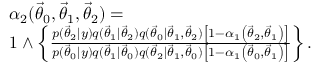Convert formula to latex. <formula><loc_0><loc_0><loc_500><loc_500>\begin{array} { r l } & { \alpha _ { 2 } ( { \vec { \theta } } _ { 0 } , { \vec { \theta } } _ { 1 } , { \vec { \theta } } _ { 2 } ) = } \\ & { 1 \wedge \left \{ \frac { p ( { \vec { \theta } } _ { 2 } | y ) q ( { \vec { \theta } } _ { 1 } | { \vec { \theta } } _ { 2 } ) q ( { \vec { \theta } } _ { 0 } | { \vec { \theta } } _ { 1 } , { \vec { \theta } } _ { 2 } ) \left [ 1 - \alpha _ { 1 } \left ( { \vec { \theta } } _ { 2 } , { \vec { \theta } } _ { 1 } \right ) \right ] } { p ( { \vec { \theta } } _ { 0 } | y ) q ( { \vec { \theta } } _ { 1 } | { \vec { \theta } } _ { 0 } ) q ( { \vec { \theta } } _ { 2 } | { \vec { \theta } } _ { 1 } , { \vec { \theta } } _ { 0 } ) \left [ 1 - \alpha _ { 1 } \left ( { \vec { \theta } } _ { 0 } , { \vec { \theta } } _ { 1 } \right ) \right ] } \right \} . } \end{array}</formula> 